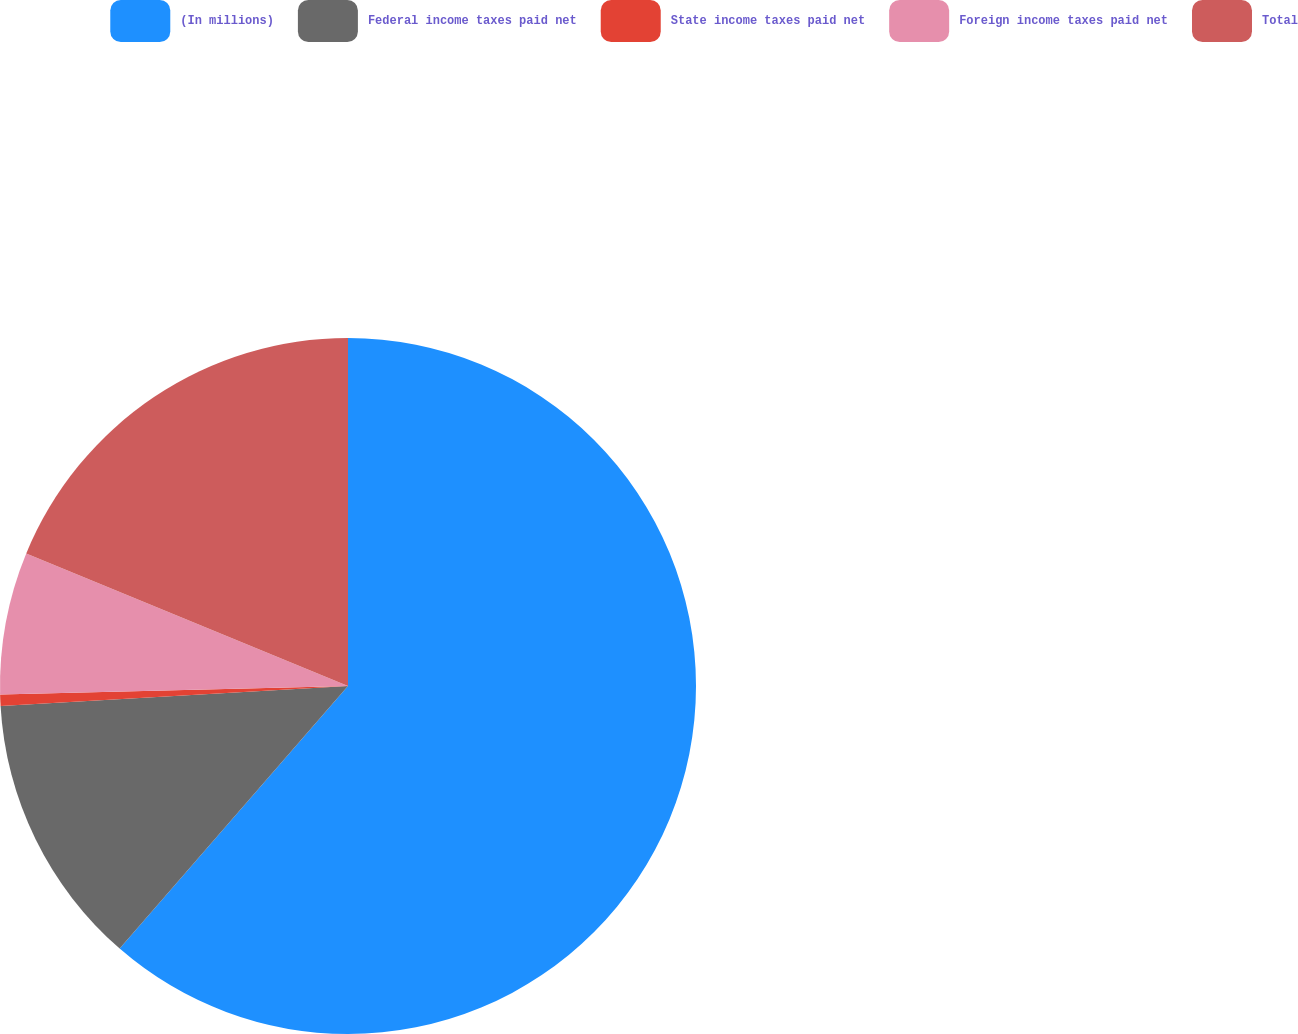Convert chart. <chart><loc_0><loc_0><loc_500><loc_500><pie_chart><fcel>(In millions)<fcel>Federal income taxes paid net<fcel>State income taxes paid net<fcel>Foreign income taxes paid net<fcel>Total<nl><fcel>61.39%<fcel>12.7%<fcel>0.52%<fcel>6.61%<fcel>18.78%<nl></chart> 